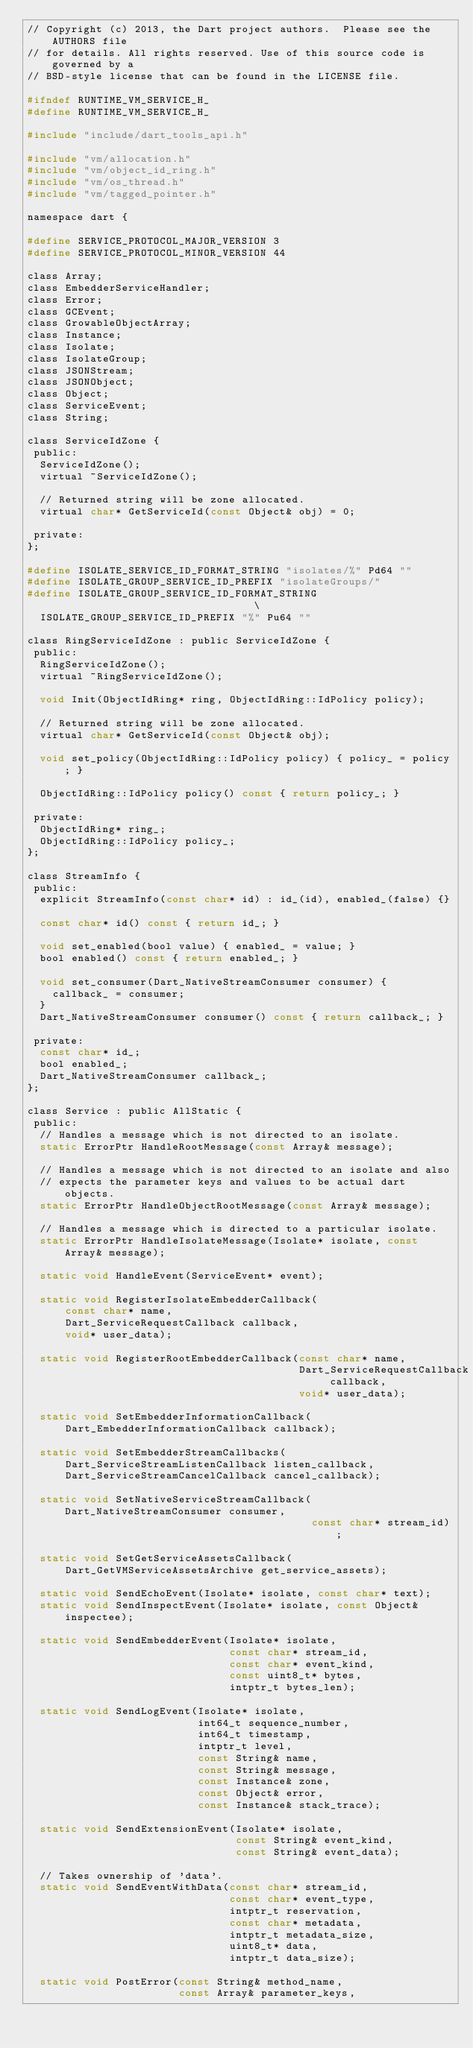Convert code to text. <code><loc_0><loc_0><loc_500><loc_500><_C_>// Copyright (c) 2013, the Dart project authors.  Please see the AUTHORS file
// for details. All rights reserved. Use of this source code is governed by a
// BSD-style license that can be found in the LICENSE file.

#ifndef RUNTIME_VM_SERVICE_H_
#define RUNTIME_VM_SERVICE_H_

#include "include/dart_tools_api.h"

#include "vm/allocation.h"
#include "vm/object_id_ring.h"
#include "vm/os_thread.h"
#include "vm/tagged_pointer.h"

namespace dart {

#define SERVICE_PROTOCOL_MAJOR_VERSION 3
#define SERVICE_PROTOCOL_MINOR_VERSION 44

class Array;
class EmbedderServiceHandler;
class Error;
class GCEvent;
class GrowableObjectArray;
class Instance;
class Isolate;
class IsolateGroup;
class JSONStream;
class JSONObject;
class Object;
class ServiceEvent;
class String;

class ServiceIdZone {
 public:
  ServiceIdZone();
  virtual ~ServiceIdZone();

  // Returned string will be zone allocated.
  virtual char* GetServiceId(const Object& obj) = 0;

 private:
};

#define ISOLATE_SERVICE_ID_FORMAT_STRING "isolates/%" Pd64 ""
#define ISOLATE_GROUP_SERVICE_ID_PREFIX "isolateGroups/"
#define ISOLATE_GROUP_SERVICE_ID_FORMAT_STRING                                 \
  ISOLATE_GROUP_SERVICE_ID_PREFIX "%" Pu64 ""

class RingServiceIdZone : public ServiceIdZone {
 public:
  RingServiceIdZone();
  virtual ~RingServiceIdZone();

  void Init(ObjectIdRing* ring, ObjectIdRing::IdPolicy policy);

  // Returned string will be zone allocated.
  virtual char* GetServiceId(const Object& obj);

  void set_policy(ObjectIdRing::IdPolicy policy) { policy_ = policy; }

  ObjectIdRing::IdPolicy policy() const { return policy_; }

 private:
  ObjectIdRing* ring_;
  ObjectIdRing::IdPolicy policy_;
};

class StreamInfo {
 public:
  explicit StreamInfo(const char* id) : id_(id), enabled_(false) {}

  const char* id() const { return id_; }

  void set_enabled(bool value) { enabled_ = value; }
  bool enabled() const { return enabled_; }

  void set_consumer(Dart_NativeStreamConsumer consumer) {
    callback_ = consumer;
  }
  Dart_NativeStreamConsumer consumer() const { return callback_; }

 private:
  const char* id_;
  bool enabled_;
  Dart_NativeStreamConsumer callback_;
};

class Service : public AllStatic {
 public:
  // Handles a message which is not directed to an isolate.
  static ErrorPtr HandleRootMessage(const Array& message);

  // Handles a message which is not directed to an isolate and also
  // expects the parameter keys and values to be actual dart objects.
  static ErrorPtr HandleObjectRootMessage(const Array& message);

  // Handles a message which is directed to a particular isolate.
  static ErrorPtr HandleIsolateMessage(Isolate* isolate, const Array& message);

  static void HandleEvent(ServiceEvent* event);

  static void RegisterIsolateEmbedderCallback(
      const char* name,
      Dart_ServiceRequestCallback callback,
      void* user_data);

  static void RegisterRootEmbedderCallback(const char* name,
                                           Dart_ServiceRequestCallback callback,
                                           void* user_data);

  static void SetEmbedderInformationCallback(
      Dart_EmbedderInformationCallback callback);

  static void SetEmbedderStreamCallbacks(
      Dart_ServiceStreamListenCallback listen_callback,
      Dart_ServiceStreamCancelCallback cancel_callback);

  static void SetNativeServiceStreamCallback(Dart_NativeStreamConsumer consumer,
                                             const char* stream_id);

  static void SetGetServiceAssetsCallback(
      Dart_GetVMServiceAssetsArchive get_service_assets);

  static void SendEchoEvent(Isolate* isolate, const char* text);
  static void SendInspectEvent(Isolate* isolate, const Object& inspectee);

  static void SendEmbedderEvent(Isolate* isolate,
                                const char* stream_id,
                                const char* event_kind,
                                const uint8_t* bytes,
                                intptr_t bytes_len);

  static void SendLogEvent(Isolate* isolate,
                           int64_t sequence_number,
                           int64_t timestamp,
                           intptr_t level,
                           const String& name,
                           const String& message,
                           const Instance& zone,
                           const Object& error,
                           const Instance& stack_trace);

  static void SendExtensionEvent(Isolate* isolate,
                                 const String& event_kind,
                                 const String& event_data);

  // Takes ownership of 'data'.
  static void SendEventWithData(const char* stream_id,
                                const char* event_type,
                                intptr_t reservation,
                                const char* metadata,
                                intptr_t metadata_size,
                                uint8_t* data,
                                intptr_t data_size);

  static void PostError(const String& method_name,
                        const Array& parameter_keys,</code> 